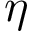<formula> <loc_0><loc_0><loc_500><loc_500>\eta</formula> 